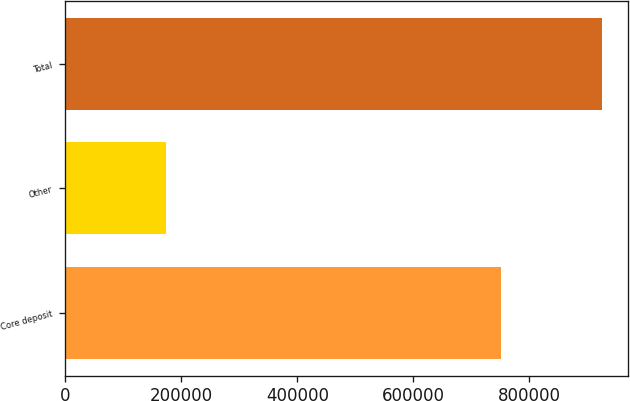<chart> <loc_0><loc_0><loc_500><loc_500><bar_chart><fcel>Core deposit<fcel>Other<fcel>Total<nl><fcel>750624<fcel>173835<fcel>924459<nl></chart> 